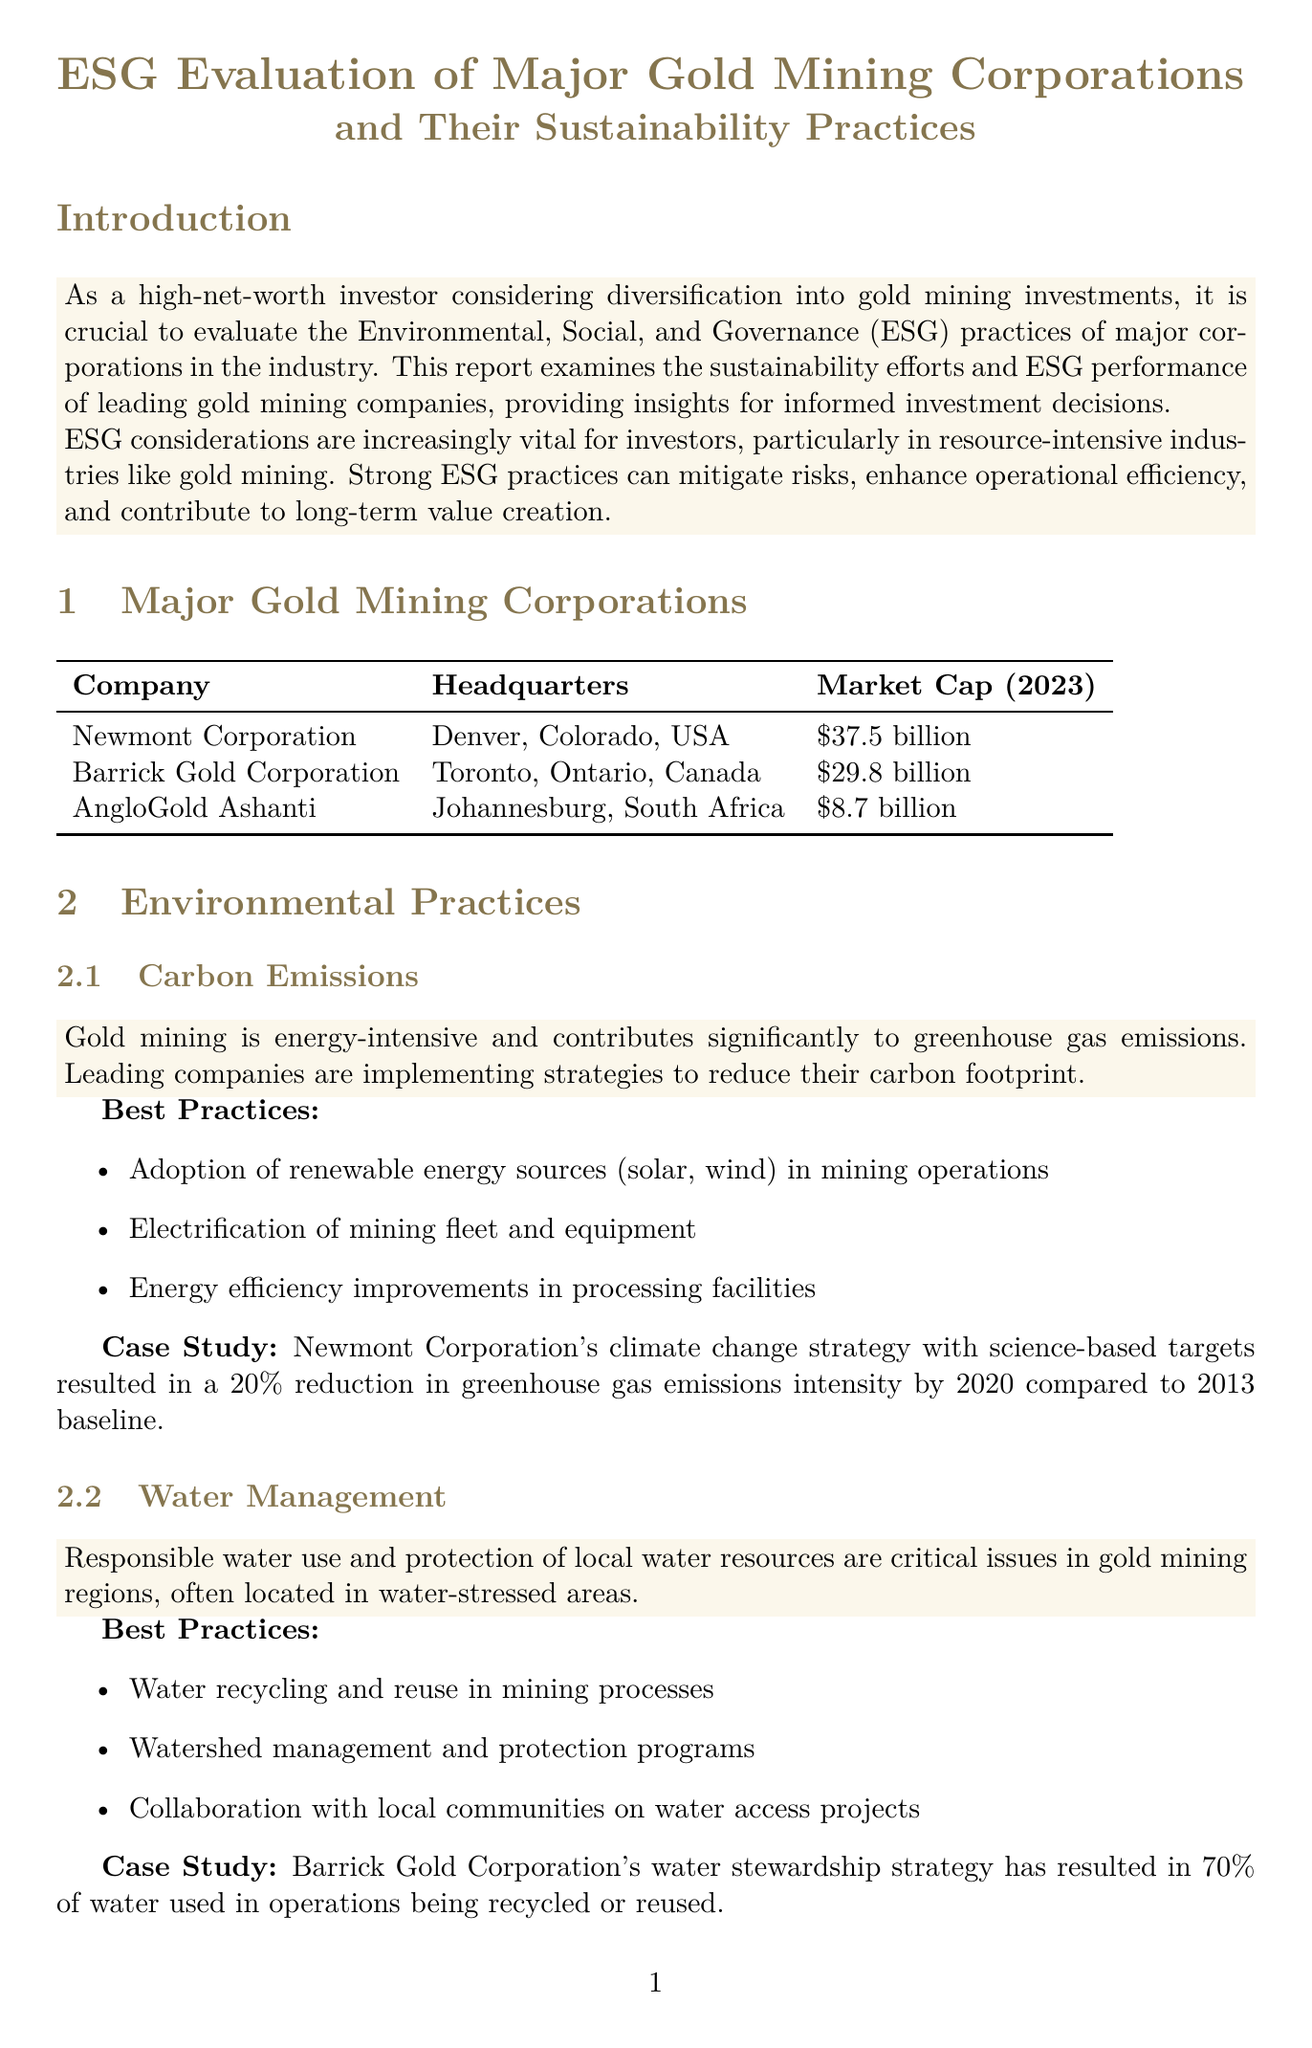What is the market cap of Newmont Corporation? The market cap is specifically stated in the document as of 2023, which is $37.5 billion.
Answer: $37.5 billion What is Barrick Gold Corporation's key initiative for water management? The document lists an initiative regarding water management that focuses on water recycling and stewardship, which leads to 70% of water used being recycled or reused.
Answer: Water stewardship strategy Which company has a malaria control program? The document indicates that AngloGold Ashanti has a specific initiative for malaria control in its operations across Africa.
Answer: AngloGold Ashanti What percentage of board members at Newmont Corporation are women or ethnically diverse? The report states that 50% of board members are women or ethnically diverse, which contributes to board diversity.
Answer: 50% What is the impact of Newmont Corporation's climate change strategy? This case study highlights the effect of Newmont's climate strategy, indicating a reduction percentage related to greenhouse gas emissions intensity.
Answer: 20% reduction How much did Newmont Corporation invest in community development projects in 2020? The document specifies the investment amount that Newmont Corporation made towards community development projects during that year.
Answer: $26.2 million Which company is ranked in the top 10% of mining companies in the Dow Jones Sustainability World Index? The report explicitly states that Barrick Gold Corporation is recognized for its sustainability practices and ranking in this index.
Answer: Barrick Gold Corporation What are the best practices for ensuring fair labor practices according to the document? The best practices for labor practices include comprehensive health and safety programs, diversity and inclusivity, which promote responsibility in the workplace.
Answer: Comprehensive health and safety programs What is the recommendation for high-net-worth investors diversifying into gold mining? The document offers a specific recommendation related to prioritizing ESG track records when making investment decisions in gold mining companies.
Answer: Prioritize companies with strong ESG track records 